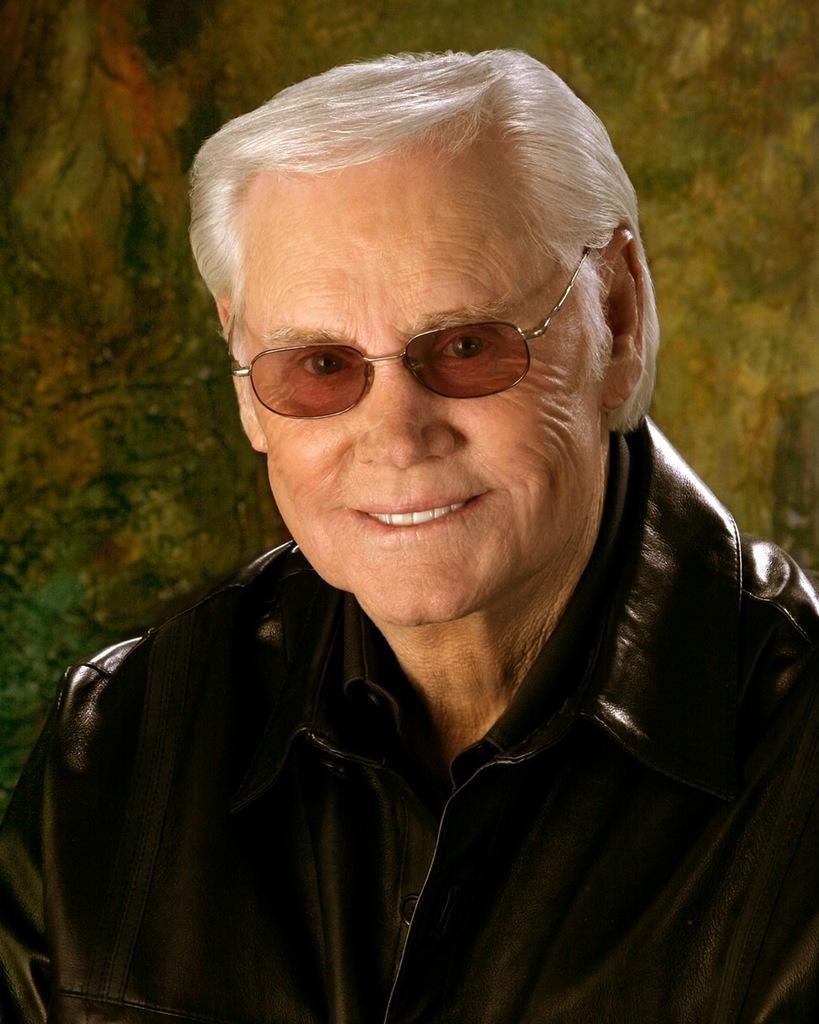In one or two sentences, can you explain what this image depicts? In this image we can see a man is smiling and he is wearing black color jacket. 